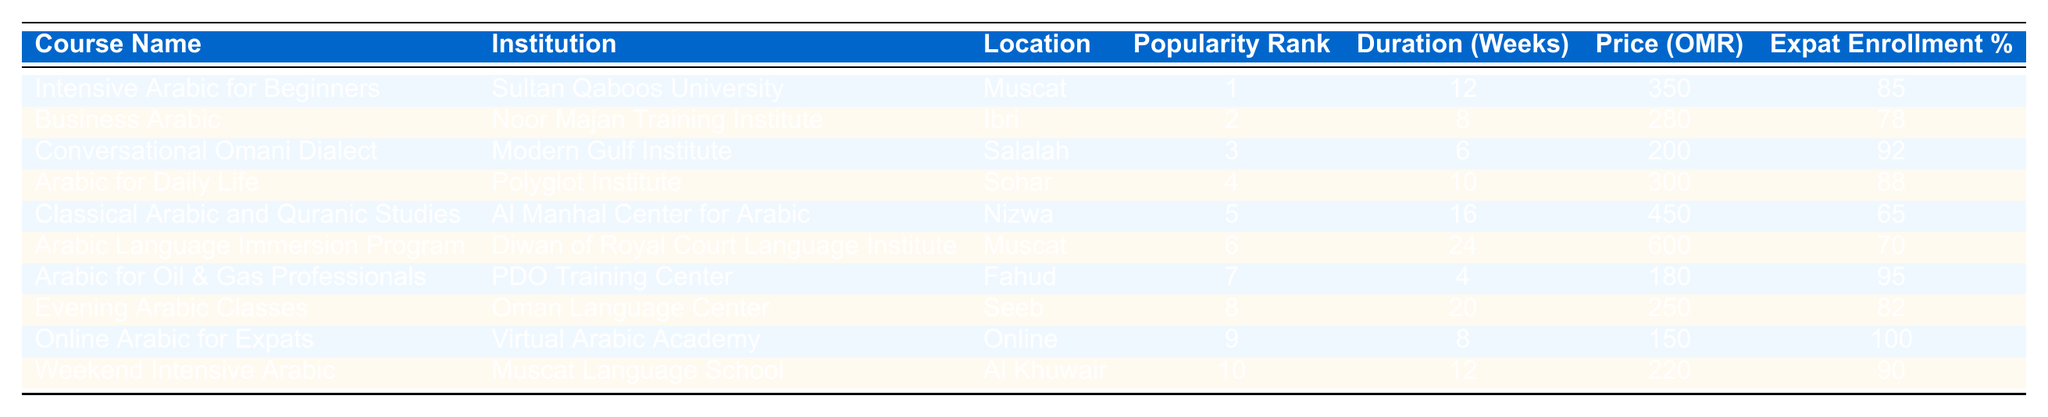What is the most popular Arabic course for expats in Oman? The table indicates that "Intensive Arabic for Beginners" has the highest popularity rank of 1 among the courses listed.
Answer: Intensive Arabic for Beginners Which institution offers the "Business Arabic" course? The course "Business Arabic" is provided by Noor Majan Training Institute as listed in the table.
Answer: Noor Majan Training Institute How long does the "Arabic for Daily Life" course last? According to the table, the duration of the "Arabic for Daily Life" course is 10 weeks.
Answer: 10 weeks What is the price of the "Classical Arabic and Quranic Studies" course? The table specifies that the price for the "Classical Arabic and Quranic Studies" course is 450 OMR.
Answer: 450 OMR Which course has the highest percentage of expat enrollment? By examining the table, "Online Arabic for Expats" has the highest expat enrollment percentage at 100%.
Answer: 100% What is the average price of all courses listed? To find the average price, sum all the prices: 350 + 280 + 200 + 300 + 450 + 600 + 180 + 250 + 150 + 220 = 2880. There are 10 courses, so the average price is 2880 / 10 = 288 OMR.
Answer: 288 OMR Is the "Arabic Language Immersion Program" located in Muscat? The table shows that the "Arabic Language Immersion Program" is offered at the Diwan of Royal Court Language Institute, which is indeed located in Muscat.
Answer: Yes Which course has the lowest expat enrollment percentage? The table indicates that "Classical Arabic and Quranic Studies" has the lowest expat enrollment percentage at 65%.
Answer: 65% If a student wants a course that lasts more than 20 weeks, which option is available? By reviewing the table, it is clear that the "Arabic Language Immersion Program" lasts for 24 weeks.
Answer: Arabic Language Immersion Program How many courses are offered in Muscat? The table shows the following courses are in Muscat: "Intensive Arabic for Beginners" and "Arabic Language Immersion Program," totaling 2 courses.
Answer: 2 courses 